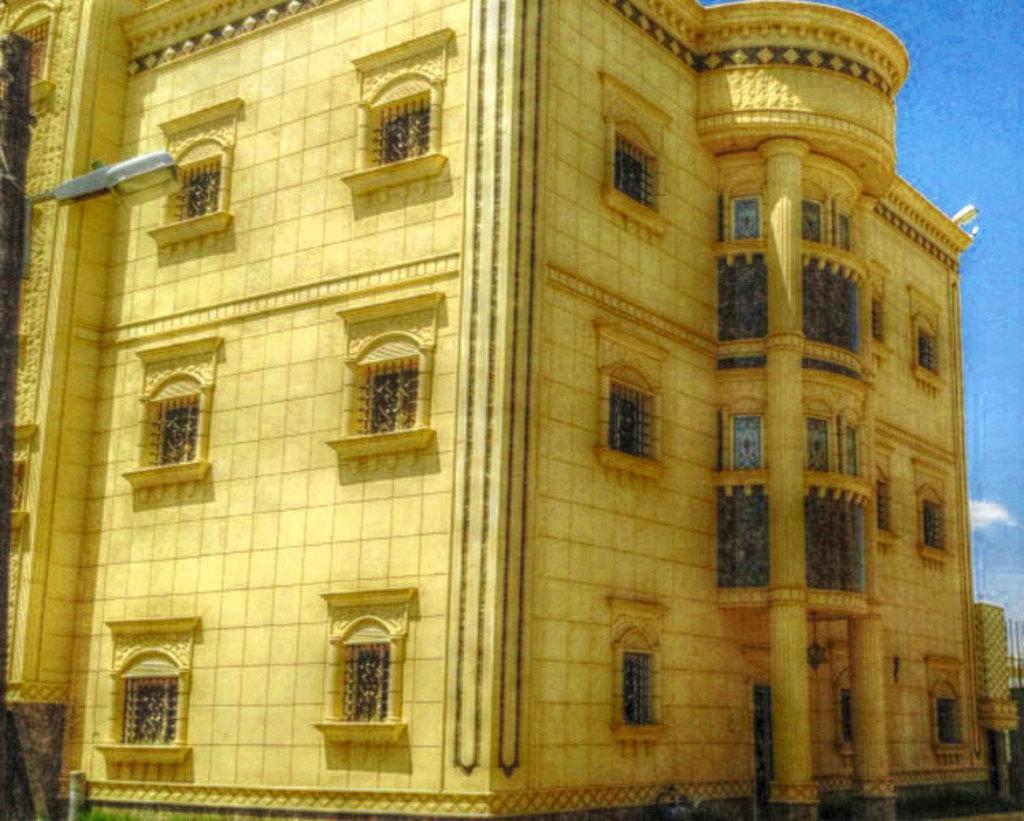Could you give a brief overview of what you see in this image? In this image there is a building and at the left side there is a street light and at the top right there is sky. 